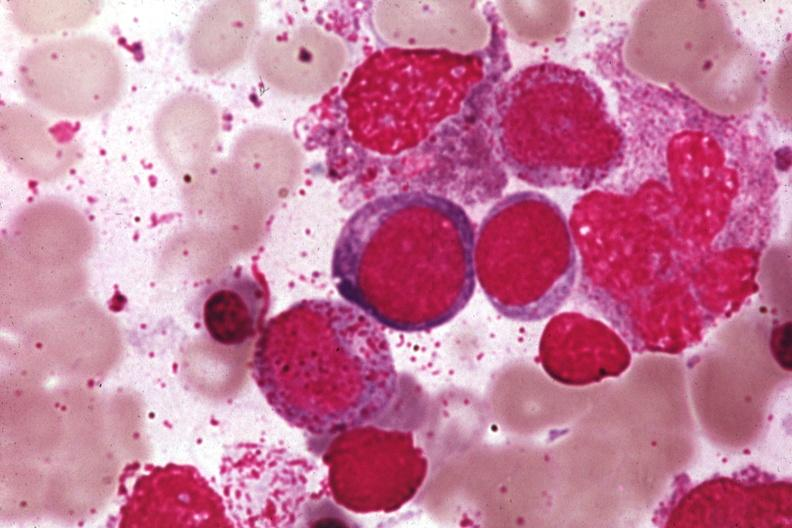s bone marrow present?
Answer the question using a single word or phrase. Yes 